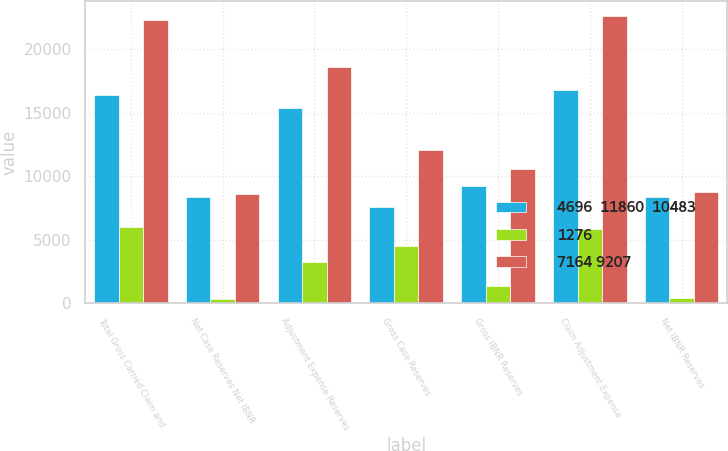Convert chart to OTSL. <chart><loc_0><loc_0><loc_500><loc_500><stacked_bar_chart><ecel><fcel>Total Gross Carried Claim and<fcel>Net Case Reserves Net IBNR<fcel>Adjustment Expense Reserves<fcel>Gross Case Reserves<fcel>Gross IBNR Reserves<fcel>Claim Adjustment Expense<fcel>Net IBNR Reserves<nl><fcel>4696  11860  10483<fcel>16371<fcel>8328<fcel>15363<fcel>7608<fcel>9191<fcel>16799<fcel>8371<nl><fcel>1276<fcel>5972<fcel>294<fcel>3213<fcel>4494<fcel>1370<fcel>5864<fcel>369<nl><fcel>7164 9207<fcel>22343<fcel>8622<fcel>18576<fcel>12102<fcel>10561<fcel>22663<fcel>8740<nl></chart> 